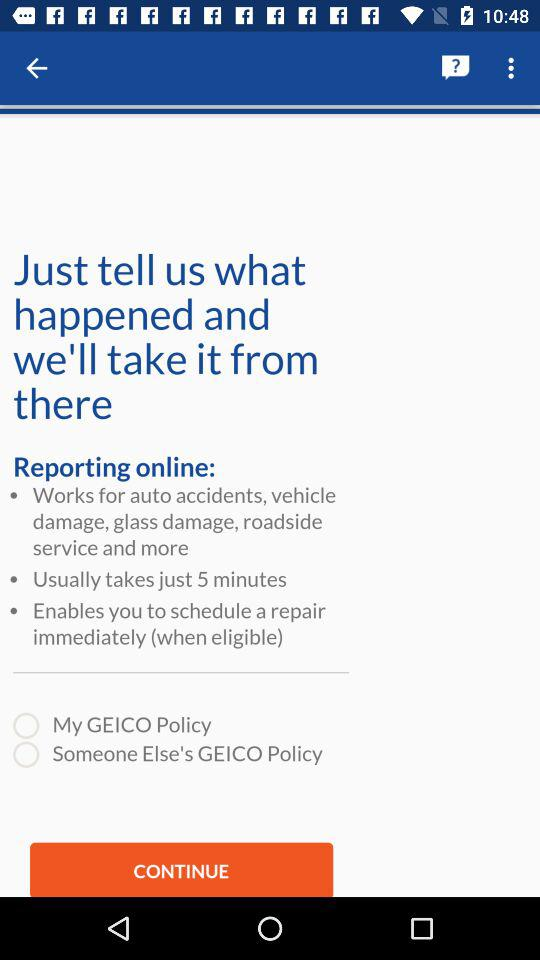What is the name of this application?
When the provided information is insufficient, respond with <no answer>. <no answer> 